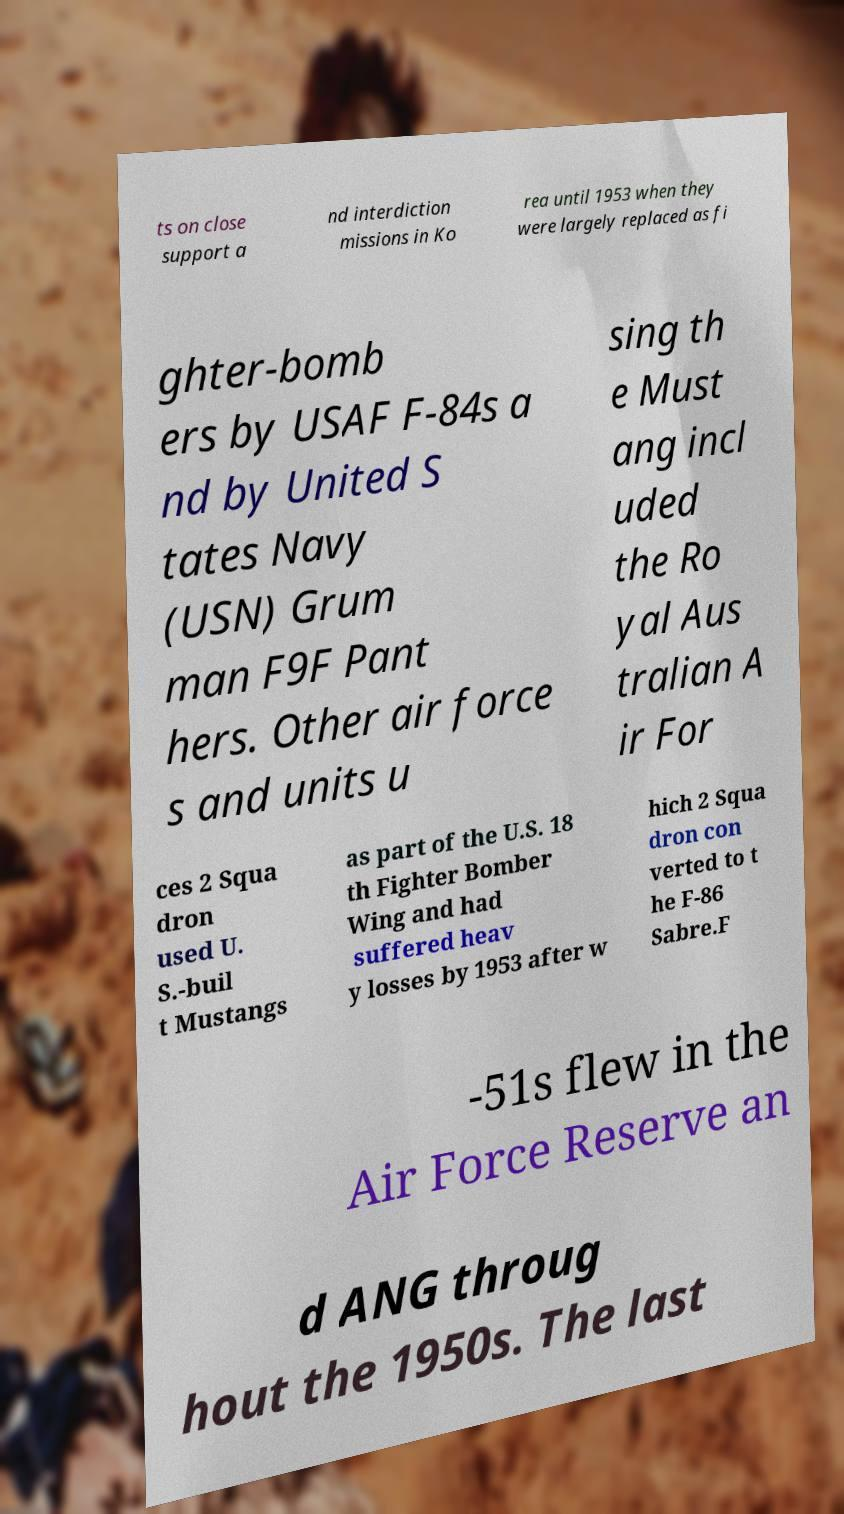Could you assist in decoding the text presented in this image and type it out clearly? ts on close support a nd interdiction missions in Ko rea until 1953 when they were largely replaced as fi ghter-bomb ers by USAF F-84s a nd by United S tates Navy (USN) Grum man F9F Pant hers. Other air force s and units u sing th e Must ang incl uded the Ro yal Aus tralian A ir For ces 2 Squa dron used U. S.-buil t Mustangs as part of the U.S. 18 th Fighter Bomber Wing and had suffered heav y losses by 1953 after w hich 2 Squa dron con verted to t he F-86 Sabre.F -51s flew in the Air Force Reserve an d ANG throug hout the 1950s. The last 